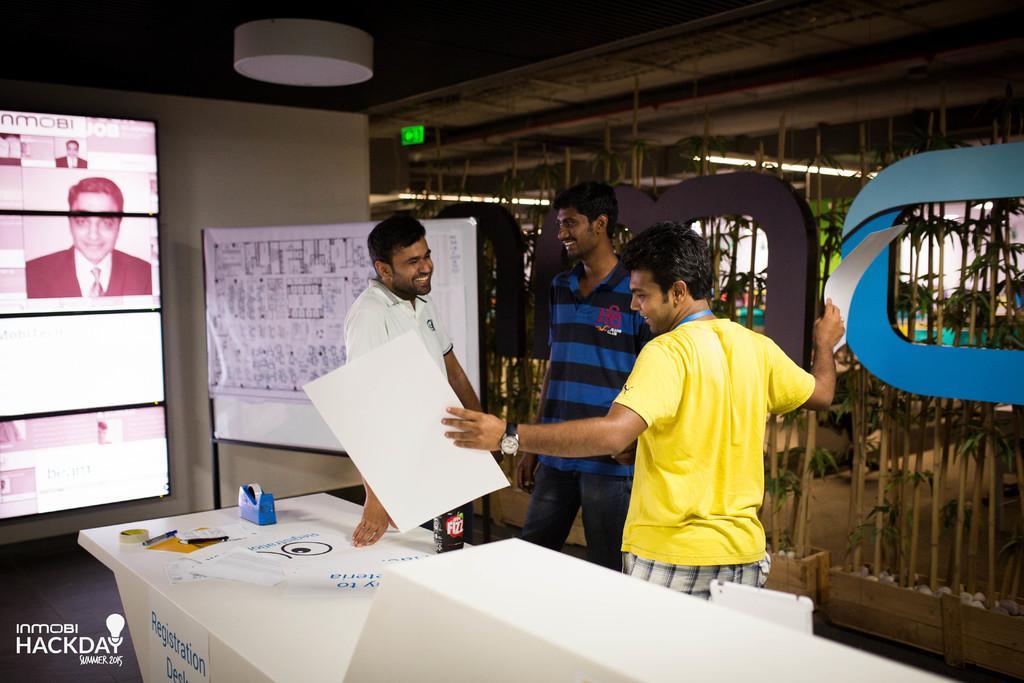Describe this image in one or two sentences. In this image three men are standing. The man who is on the the right side is wearing yellow color t-shirt and holding a paper in hand. The middle person is wearing blue color t-shirt and smiling. The man who is on the left side is smiling and looking at the person who is holding a paper in hand. In front of this people there is a table on which a bottle and few objects are placed. On the left side of the image there is a screen, beside that there a board. 